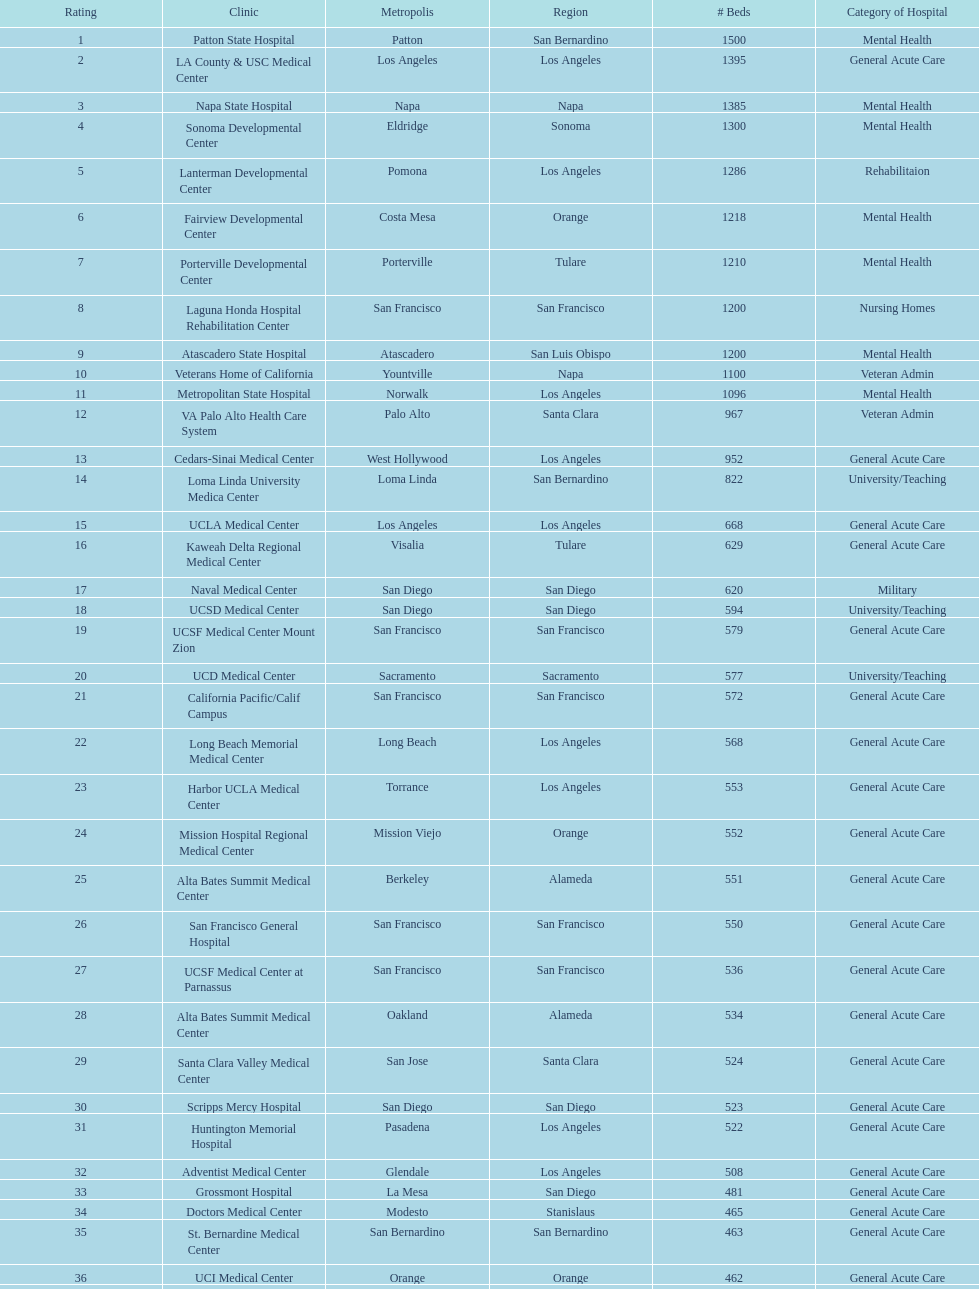How many hospitals have at least 1,000 beds? 11. 